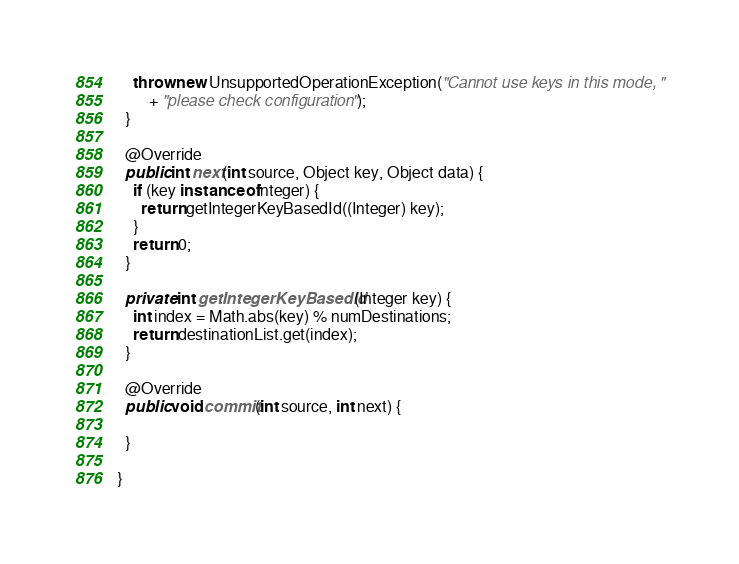<code> <loc_0><loc_0><loc_500><loc_500><_Java_>    throw new UnsupportedOperationException("Cannot use keys in this mode, "
        + "please check configuration");
  }

  @Override
  public int next(int source, Object key, Object data) {
    if (key instanceof Integer) {
      return getIntegerKeyBasedId((Integer) key);
    }
    return 0;
  }

  private int getIntegerKeyBasedId(Integer key) {
    int index = Math.abs(key) % numDestinations;
    return destinationList.get(index);
  }

  @Override
  public void commit(int source, int next) {

  }

}
</code> 